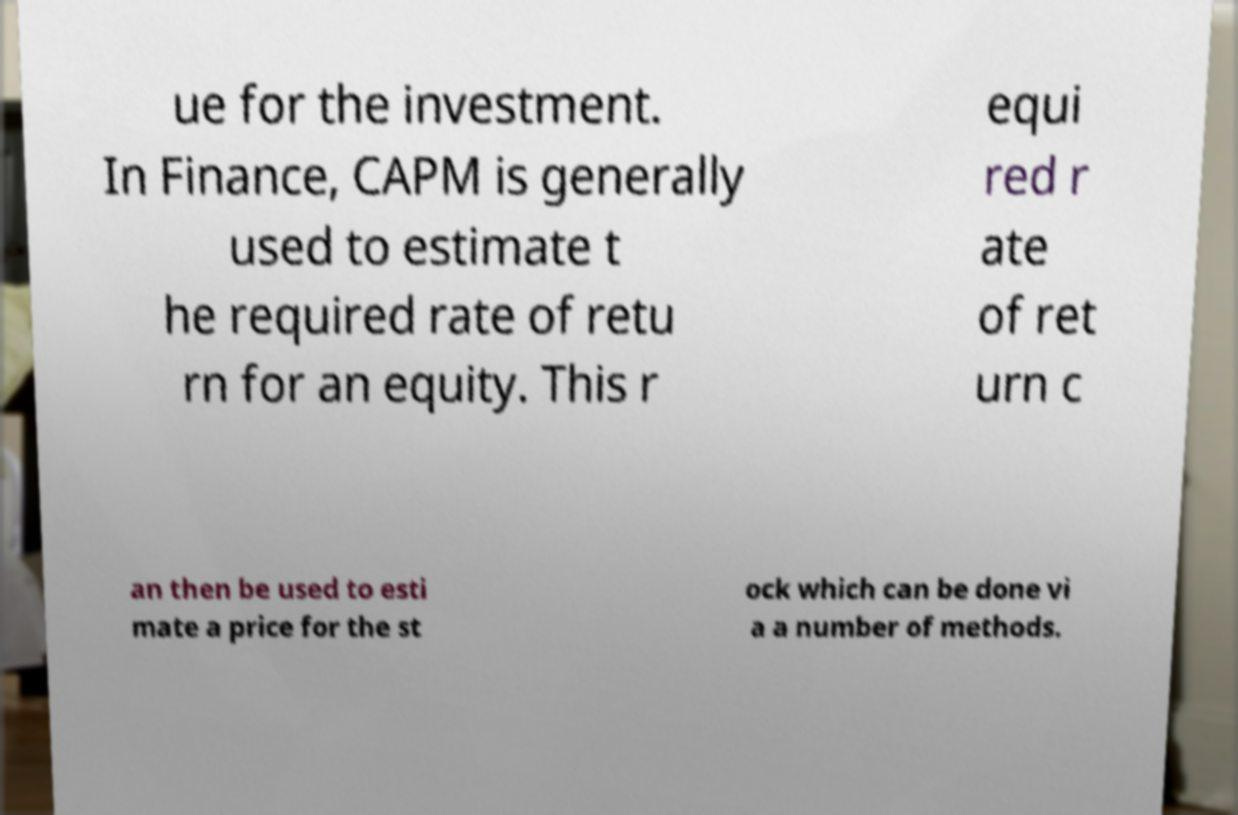Can you read and provide the text displayed in the image?This photo seems to have some interesting text. Can you extract and type it out for me? ue for the investment. In Finance, CAPM is generally used to estimate t he required rate of retu rn for an equity. This r equi red r ate of ret urn c an then be used to esti mate a price for the st ock which can be done vi a a number of methods. 